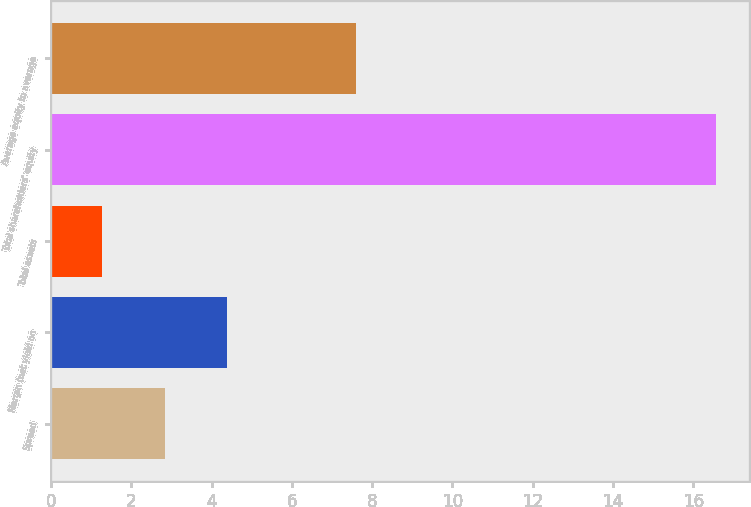<chart> <loc_0><loc_0><loc_500><loc_500><bar_chart><fcel>Spread<fcel>Margin (net yield on<fcel>Total assets<fcel>Total shareholders' equity<fcel>Average equity to average<nl><fcel>2.85<fcel>4.38<fcel>1.26<fcel>16.56<fcel>7.61<nl></chart> 